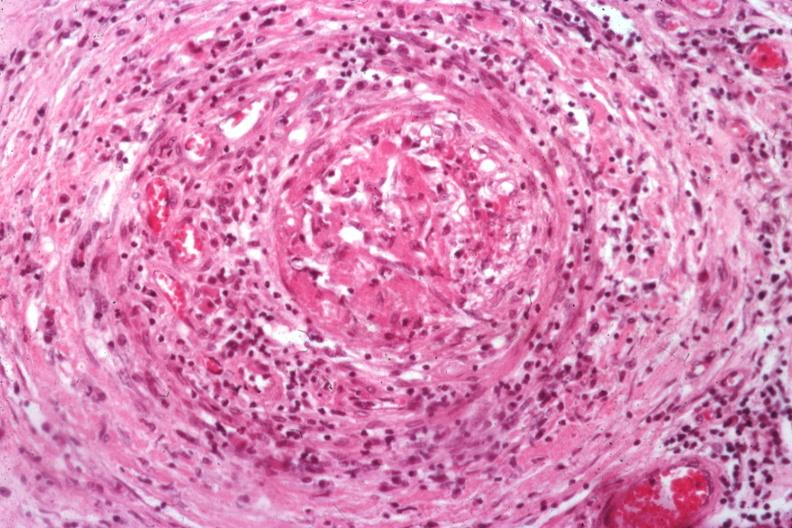s testicle present?
Answer the question using a single word or phrase. Yes 